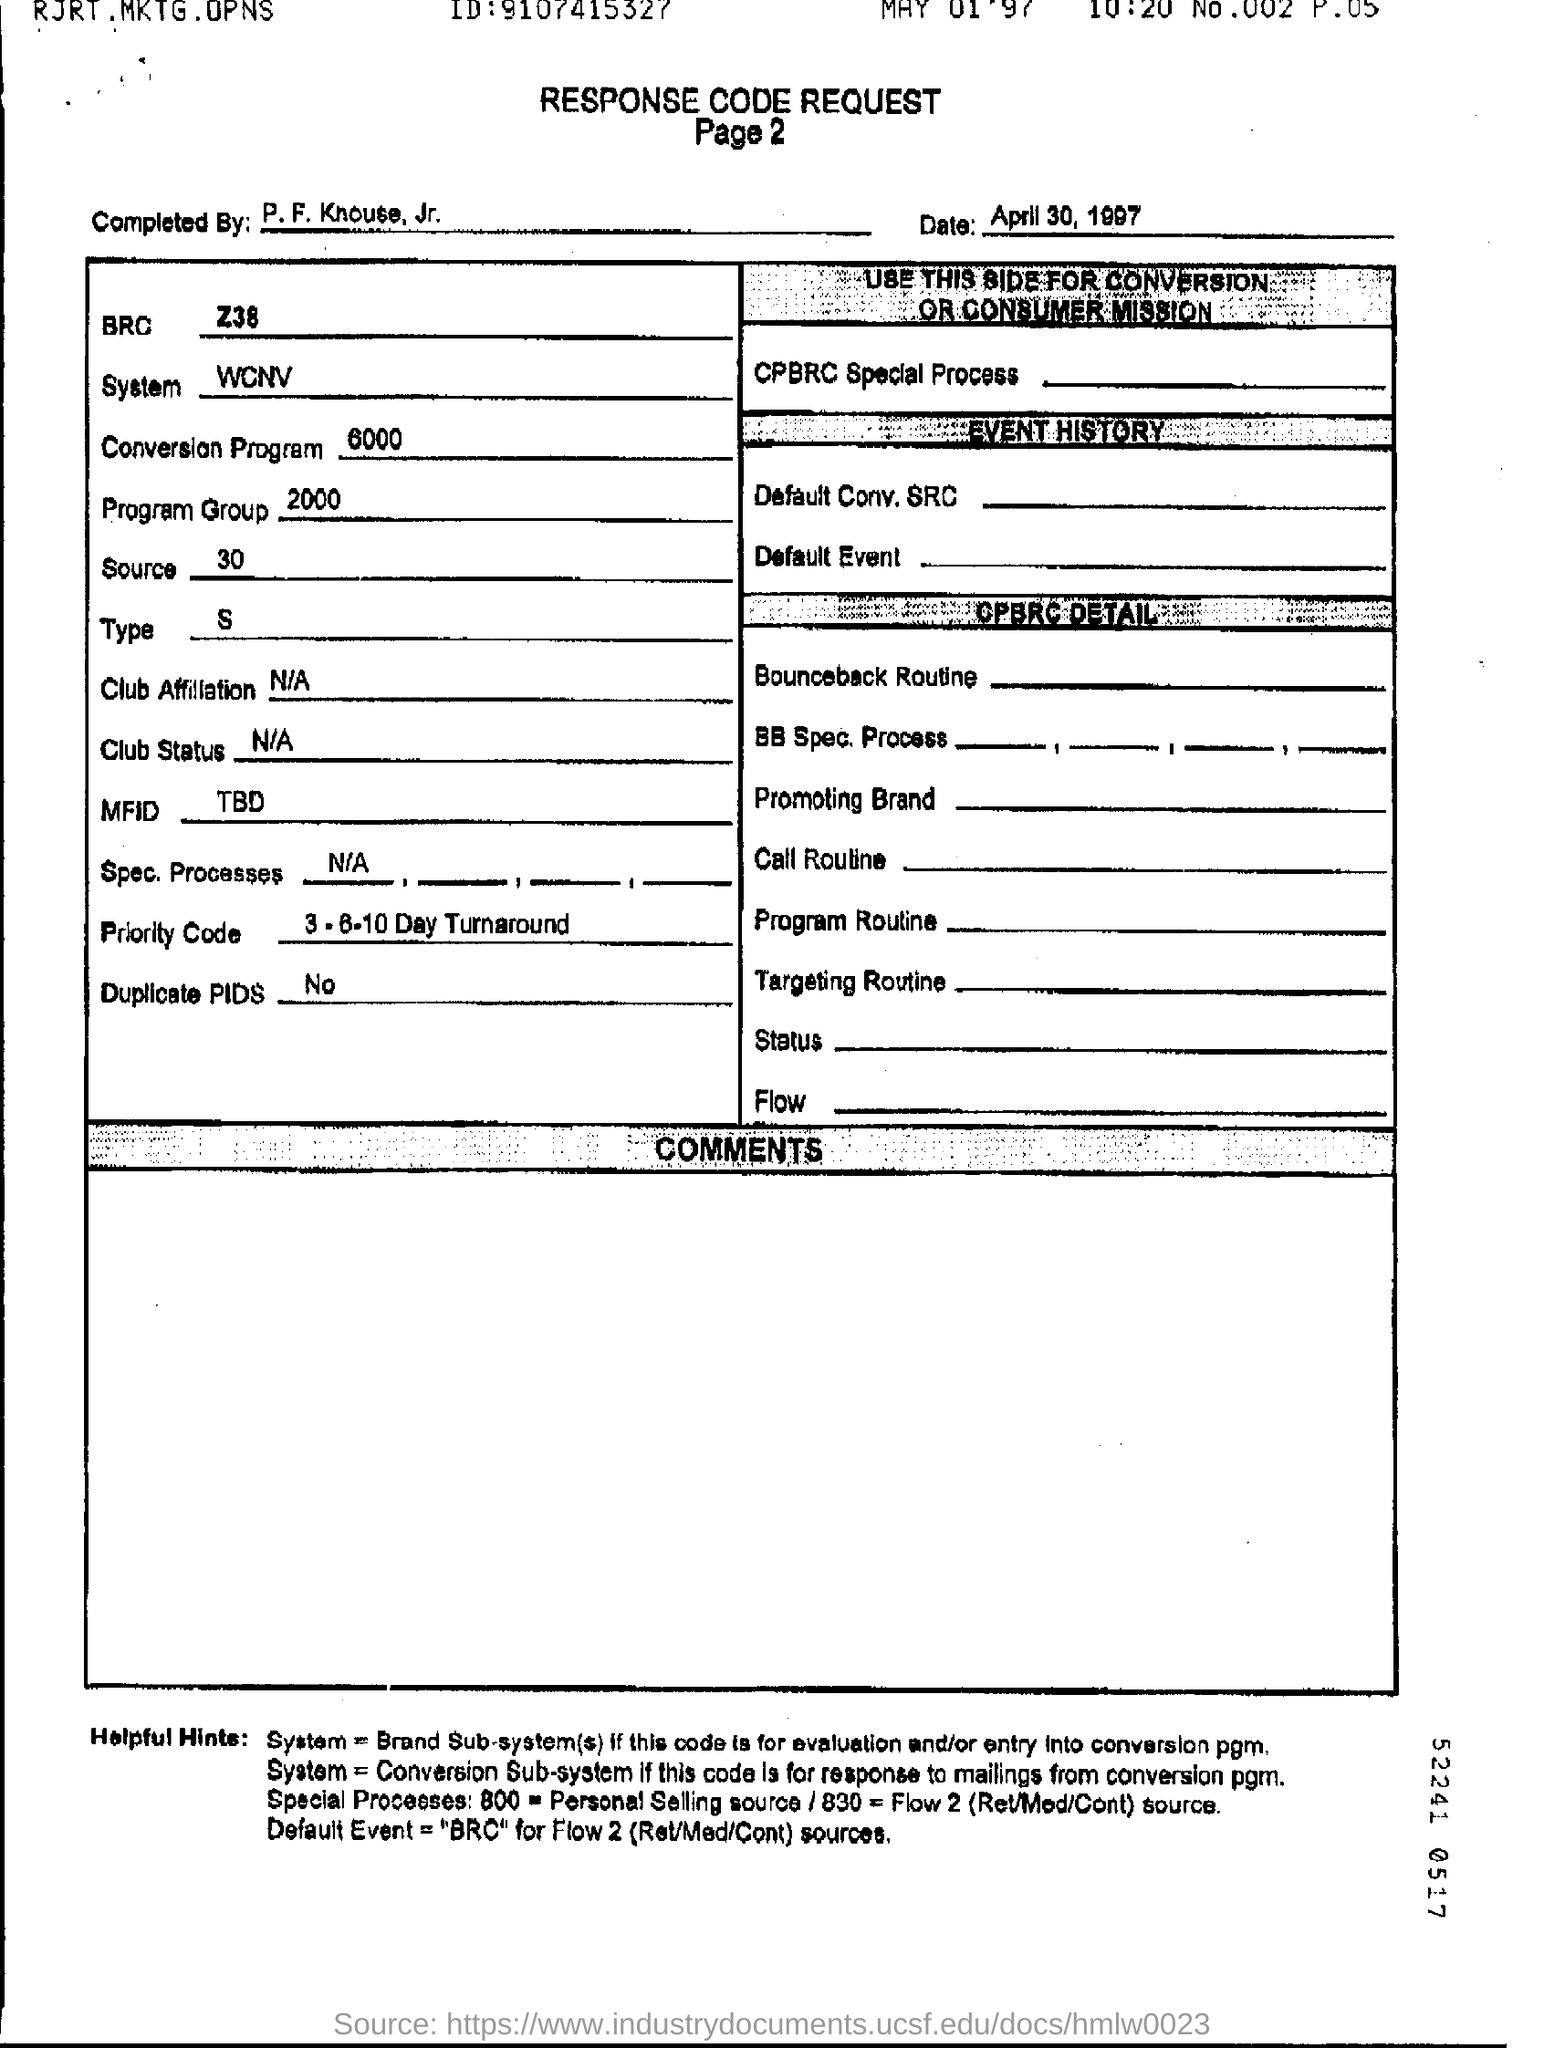Give some essential details in this illustration. There are no duplicate PIDs. The response code sheet was completed by P. F. Knouse, Jr. 